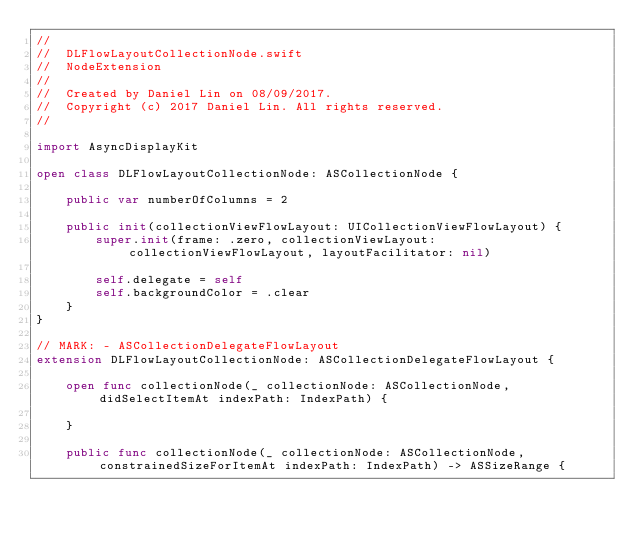<code> <loc_0><loc_0><loc_500><loc_500><_Swift_>//
//  DLFlowLayoutCollectionNode.swift
//  NodeExtension
//
//  Created by Daniel Lin on 08/09/2017.
//  Copyright (c) 2017 Daniel Lin. All rights reserved.
//

import AsyncDisplayKit

open class DLFlowLayoutCollectionNode: ASCollectionNode {
    
    public var numberOfColumns = 2

    public init(collectionViewFlowLayout: UICollectionViewFlowLayout) {
        super.init(frame: .zero, collectionViewLayout: collectionViewFlowLayout, layoutFacilitator: nil)
        
        self.delegate = self
        self.backgroundColor = .clear
    }
}

// MARK: - ASCollectionDelegateFlowLayout
extension DLFlowLayoutCollectionNode: ASCollectionDelegateFlowLayout {
    
    open func collectionNode(_ collectionNode: ASCollectionNode, didSelectItemAt indexPath: IndexPath) {
        
    }
    
    public func collectionNode(_ collectionNode: ASCollectionNode, constrainedSizeForItemAt indexPath: IndexPath) -> ASSizeRange {</code> 